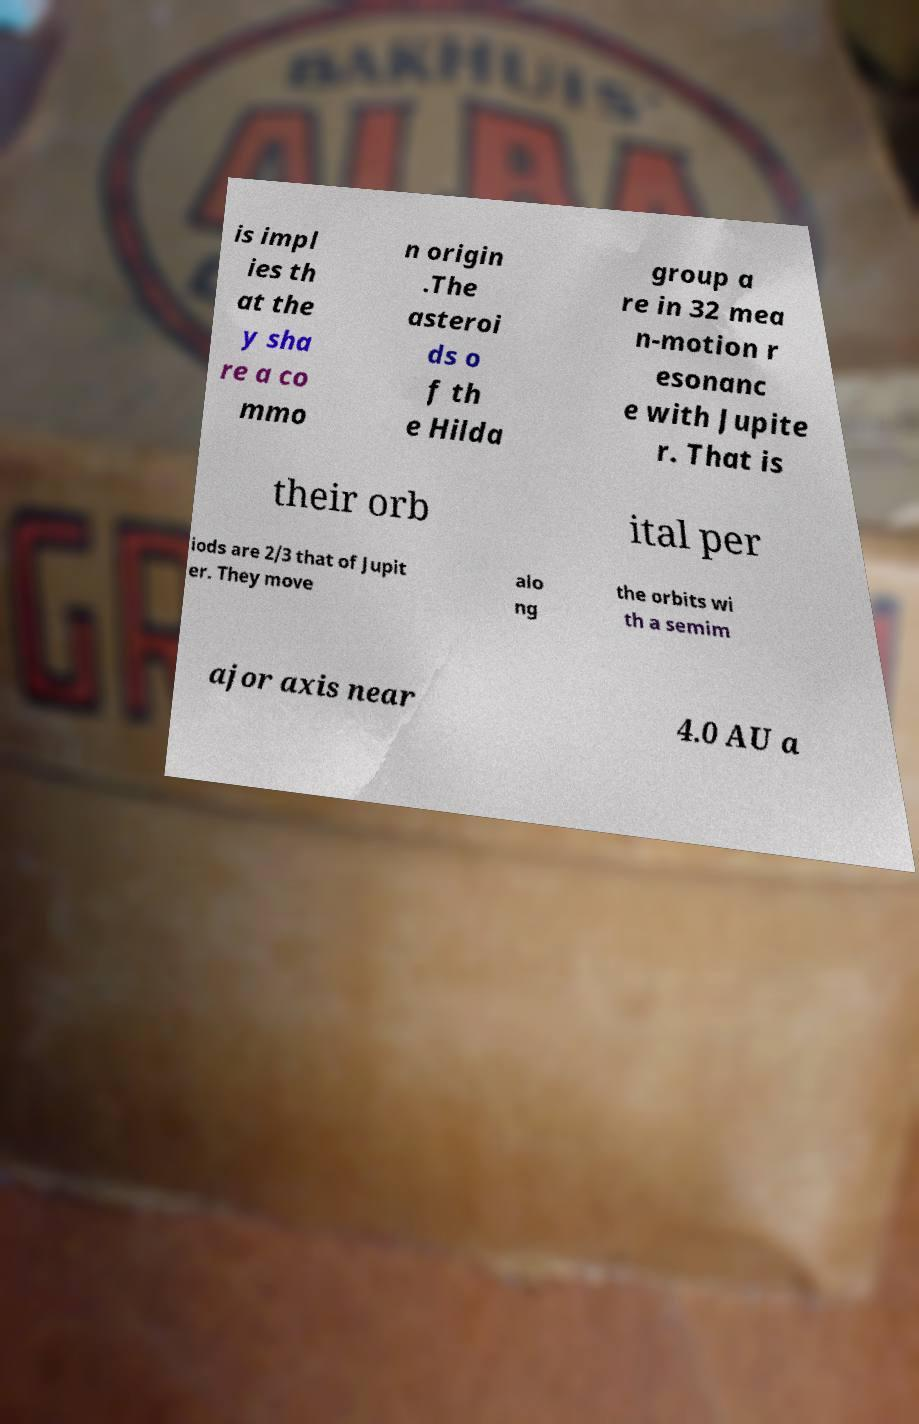There's text embedded in this image that I need extracted. Can you transcribe it verbatim? is impl ies th at the y sha re a co mmo n origin .The asteroi ds o f th e Hilda group a re in 32 mea n-motion r esonanc e with Jupite r. That is their orb ital per iods are 2/3 that of Jupit er. They move alo ng the orbits wi th a semim ajor axis near 4.0 AU a 